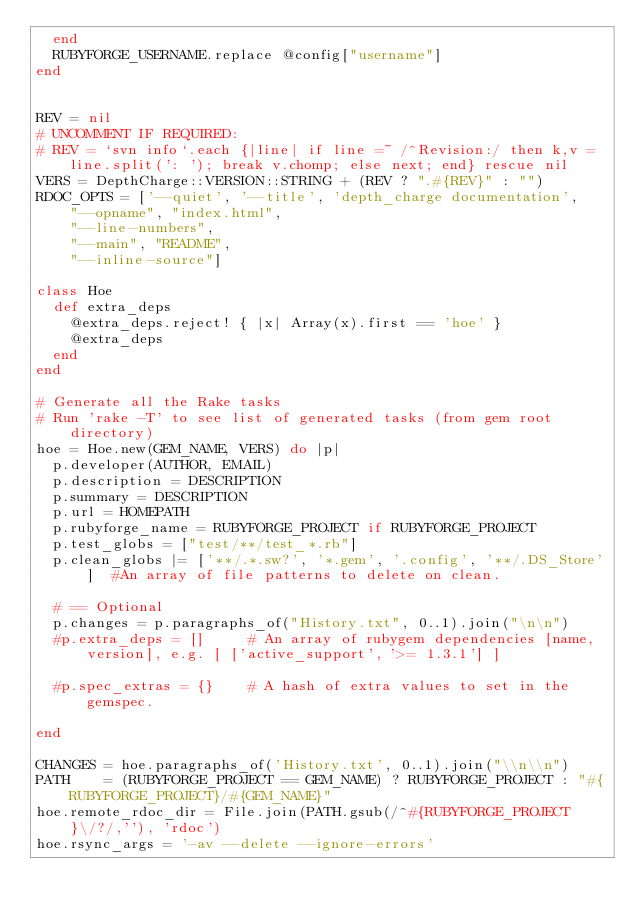<code> <loc_0><loc_0><loc_500><loc_500><_Ruby_>  end
  RUBYFORGE_USERNAME.replace @config["username"]
end


REV = nil 
# UNCOMMENT IF REQUIRED: 
# REV = `svn info`.each {|line| if line =~ /^Revision:/ then k,v = line.split(': '); break v.chomp; else next; end} rescue nil
VERS = DepthCharge::VERSION::STRING + (REV ? ".#{REV}" : "")
RDOC_OPTS = ['--quiet', '--title', 'depth_charge documentation',
    "--opname", "index.html",
    "--line-numbers", 
    "--main", "README",
    "--inline-source"]

class Hoe
  def extra_deps 
    @extra_deps.reject! { |x| Array(x).first == 'hoe' } 
    @extra_deps
  end 
end

# Generate all the Rake tasks
# Run 'rake -T' to see list of generated tasks (from gem root directory)
hoe = Hoe.new(GEM_NAME, VERS) do |p|
  p.developer(AUTHOR, EMAIL)
  p.description = DESCRIPTION
  p.summary = DESCRIPTION
  p.url = HOMEPATH
  p.rubyforge_name = RUBYFORGE_PROJECT if RUBYFORGE_PROJECT
  p.test_globs = ["test/**/test_*.rb"]
  p.clean_globs |= ['**/.*.sw?', '*.gem', '.config', '**/.DS_Store']  #An array of file patterns to delete on clean.
  
  # == Optional
  p.changes = p.paragraphs_of("History.txt", 0..1).join("\n\n")
  #p.extra_deps = []     # An array of rubygem dependencies [name, version], e.g. [ ['active_support', '>= 1.3.1'] ]
  
  #p.spec_extras = {}    # A hash of extra values to set in the gemspec.
  
end

CHANGES = hoe.paragraphs_of('History.txt', 0..1).join("\\n\\n")
PATH    = (RUBYFORGE_PROJECT == GEM_NAME) ? RUBYFORGE_PROJECT : "#{RUBYFORGE_PROJECT}/#{GEM_NAME}"
hoe.remote_rdoc_dir = File.join(PATH.gsub(/^#{RUBYFORGE_PROJECT}\/?/,''), 'rdoc')
hoe.rsync_args = '-av --delete --ignore-errors'</code> 